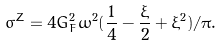Convert formula to latex. <formula><loc_0><loc_0><loc_500><loc_500>\sigma ^ { Z } = 4 G _ { F } ^ { 2 } \omega ^ { 2 } ( \frac { 1 } { 4 } - \frac { \xi } 2 + \xi ^ { 2 } ) / \pi .</formula> 